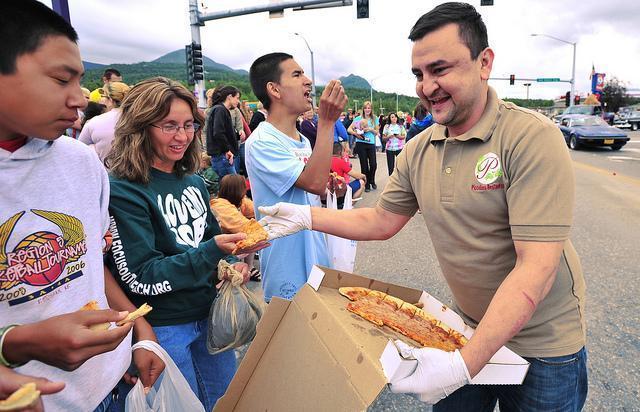How many people are in the photo?
Give a very brief answer. 5. 